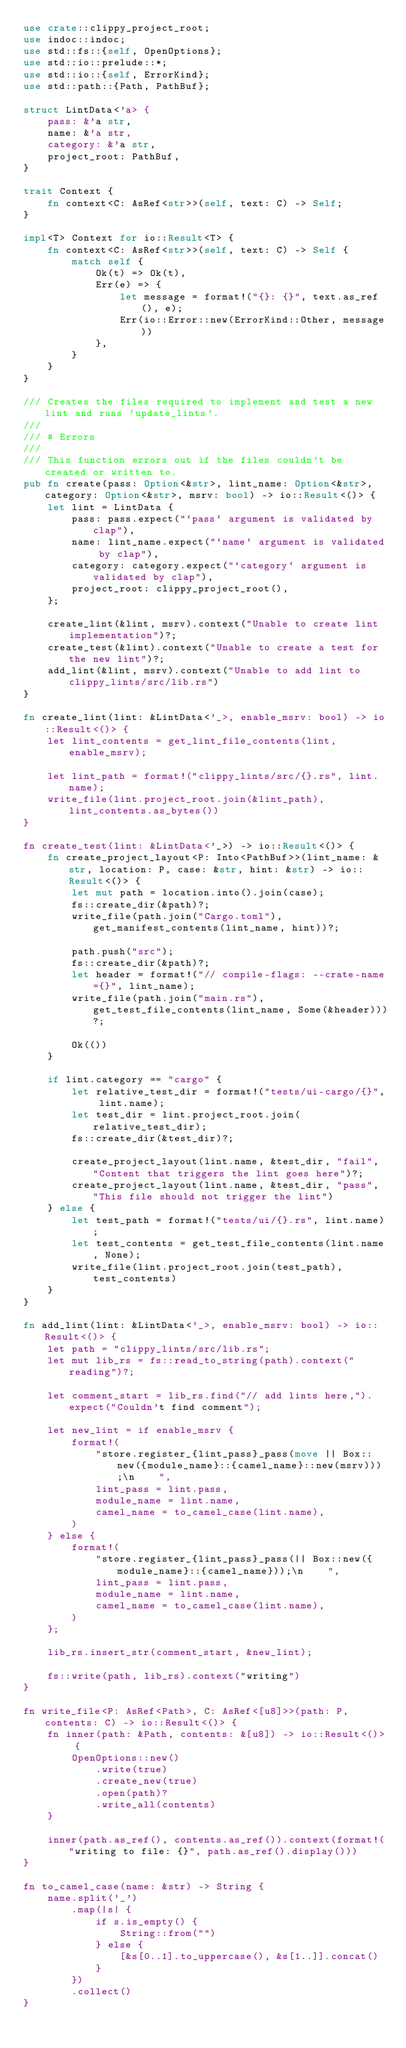<code> <loc_0><loc_0><loc_500><loc_500><_Rust_>use crate::clippy_project_root;
use indoc::indoc;
use std::fs::{self, OpenOptions};
use std::io::prelude::*;
use std::io::{self, ErrorKind};
use std::path::{Path, PathBuf};

struct LintData<'a> {
    pass: &'a str,
    name: &'a str,
    category: &'a str,
    project_root: PathBuf,
}

trait Context {
    fn context<C: AsRef<str>>(self, text: C) -> Self;
}

impl<T> Context for io::Result<T> {
    fn context<C: AsRef<str>>(self, text: C) -> Self {
        match self {
            Ok(t) => Ok(t),
            Err(e) => {
                let message = format!("{}: {}", text.as_ref(), e);
                Err(io::Error::new(ErrorKind::Other, message))
            },
        }
    }
}

/// Creates the files required to implement and test a new lint and runs `update_lints`.
///
/// # Errors
///
/// This function errors out if the files couldn't be created or written to.
pub fn create(pass: Option<&str>, lint_name: Option<&str>, category: Option<&str>, msrv: bool) -> io::Result<()> {
    let lint = LintData {
        pass: pass.expect("`pass` argument is validated by clap"),
        name: lint_name.expect("`name` argument is validated by clap"),
        category: category.expect("`category` argument is validated by clap"),
        project_root: clippy_project_root(),
    };

    create_lint(&lint, msrv).context("Unable to create lint implementation")?;
    create_test(&lint).context("Unable to create a test for the new lint")?;
    add_lint(&lint, msrv).context("Unable to add lint to clippy_lints/src/lib.rs")
}

fn create_lint(lint: &LintData<'_>, enable_msrv: bool) -> io::Result<()> {
    let lint_contents = get_lint_file_contents(lint, enable_msrv);

    let lint_path = format!("clippy_lints/src/{}.rs", lint.name);
    write_file(lint.project_root.join(&lint_path), lint_contents.as_bytes())
}

fn create_test(lint: &LintData<'_>) -> io::Result<()> {
    fn create_project_layout<P: Into<PathBuf>>(lint_name: &str, location: P, case: &str, hint: &str) -> io::Result<()> {
        let mut path = location.into().join(case);
        fs::create_dir(&path)?;
        write_file(path.join("Cargo.toml"), get_manifest_contents(lint_name, hint))?;

        path.push("src");
        fs::create_dir(&path)?;
        let header = format!("// compile-flags: --crate-name={}", lint_name);
        write_file(path.join("main.rs"), get_test_file_contents(lint_name, Some(&header)))?;

        Ok(())
    }

    if lint.category == "cargo" {
        let relative_test_dir = format!("tests/ui-cargo/{}", lint.name);
        let test_dir = lint.project_root.join(relative_test_dir);
        fs::create_dir(&test_dir)?;

        create_project_layout(lint.name, &test_dir, "fail", "Content that triggers the lint goes here")?;
        create_project_layout(lint.name, &test_dir, "pass", "This file should not trigger the lint")
    } else {
        let test_path = format!("tests/ui/{}.rs", lint.name);
        let test_contents = get_test_file_contents(lint.name, None);
        write_file(lint.project_root.join(test_path), test_contents)
    }
}

fn add_lint(lint: &LintData<'_>, enable_msrv: bool) -> io::Result<()> {
    let path = "clippy_lints/src/lib.rs";
    let mut lib_rs = fs::read_to_string(path).context("reading")?;

    let comment_start = lib_rs.find("// add lints here,").expect("Couldn't find comment");

    let new_lint = if enable_msrv {
        format!(
            "store.register_{lint_pass}_pass(move || Box::new({module_name}::{camel_name}::new(msrv)));\n    ",
            lint_pass = lint.pass,
            module_name = lint.name,
            camel_name = to_camel_case(lint.name),
        )
    } else {
        format!(
            "store.register_{lint_pass}_pass(|| Box::new({module_name}::{camel_name}));\n    ",
            lint_pass = lint.pass,
            module_name = lint.name,
            camel_name = to_camel_case(lint.name),
        )
    };

    lib_rs.insert_str(comment_start, &new_lint);

    fs::write(path, lib_rs).context("writing")
}

fn write_file<P: AsRef<Path>, C: AsRef<[u8]>>(path: P, contents: C) -> io::Result<()> {
    fn inner(path: &Path, contents: &[u8]) -> io::Result<()> {
        OpenOptions::new()
            .write(true)
            .create_new(true)
            .open(path)?
            .write_all(contents)
    }

    inner(path.as_ref(), contents.as_ref()).context(format!("writing to file: {}", path.as_ref().display()))
}

fn to_camel_case(name: &str) -> String {
    name.split('_')
        .map(|s| {
            if s.is_empty() {
                String::from("")
            } else {
                [&s[0..1].to_uppercase(), &s[1..]].concat()
            }
        })
        .collect()
}
</code> 